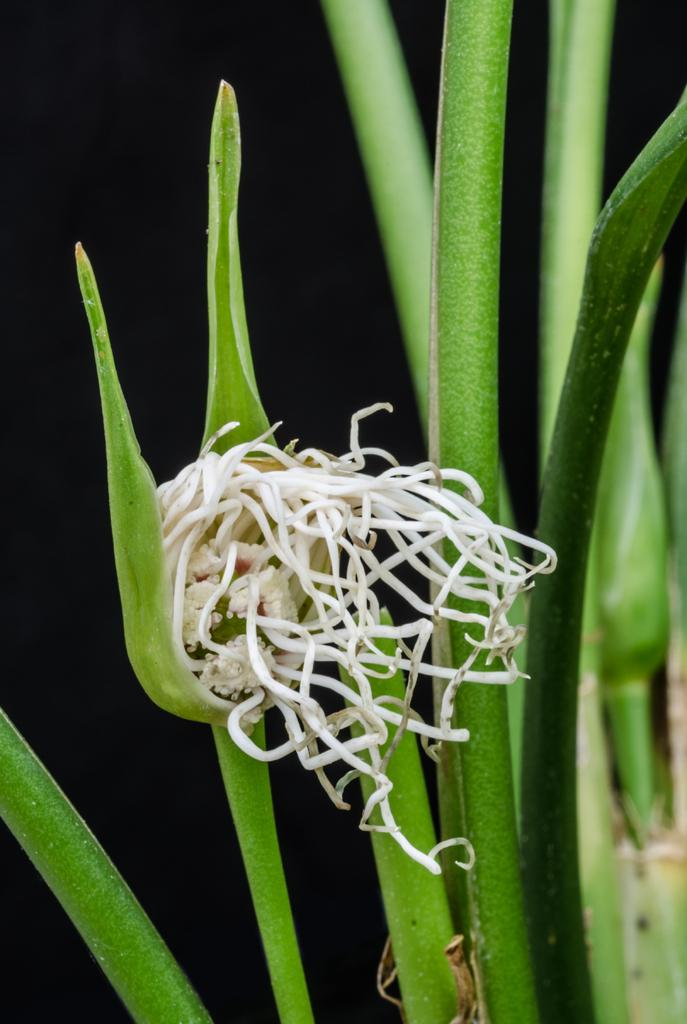What is present in the image? There is a plant in the image. Can you describe the plant in more detail? The plant has a flower. What type of powder is being used to create the sleet in the image? There is no powder or sleet present in the image; it features a plant with a flower. 